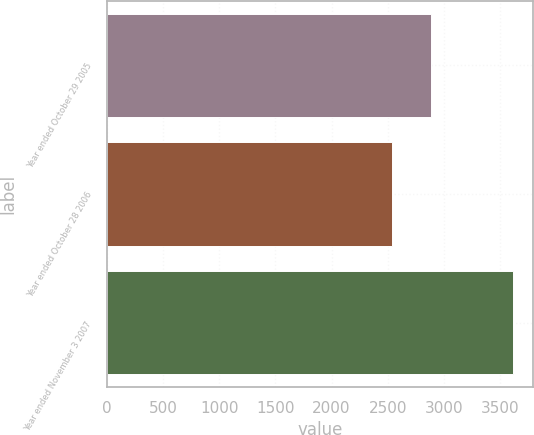Convert chart. <chart><loc_0><loc_0><loc_500><loc_500><bar_chart><fcel>Year ended October 29 2005<fcel>Year ended October 28 2006<fcel>Year ended November 3 2007<nl><fcel>2882<fcel>2533<fcel>3611<nl></chart> 